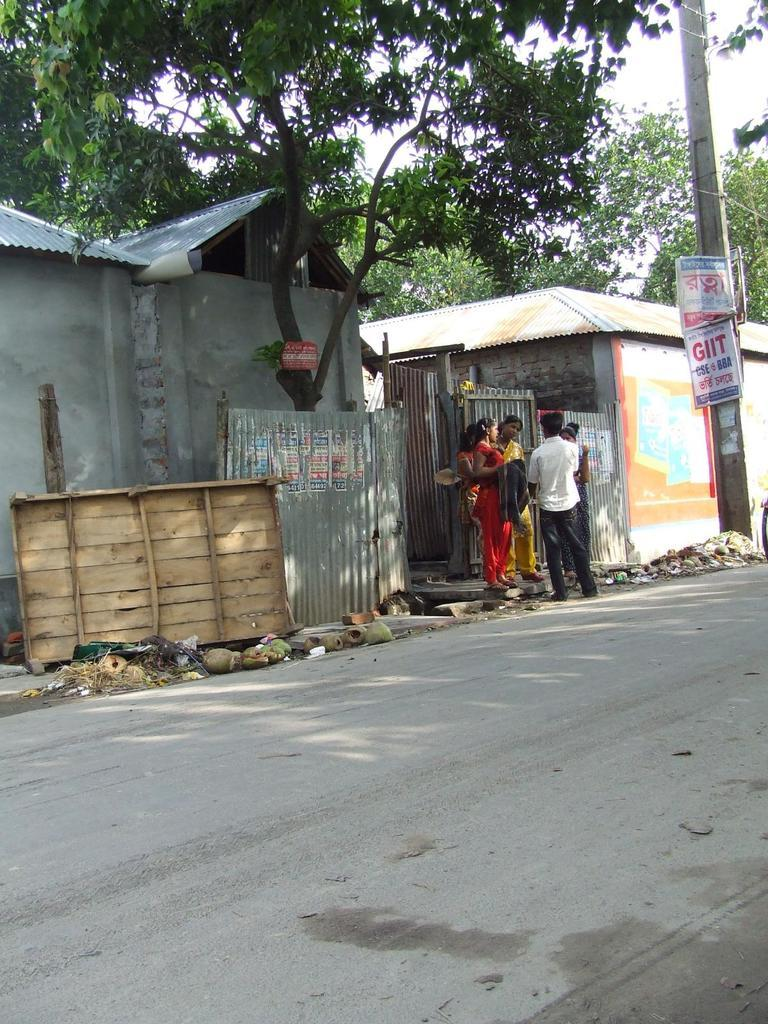What is located in the foreground of the image? There is a road in the foreground of the image. What can be seen in the background of the image? In the background of the image, there is a pole, banners, persons standing, a wooden object, metal sheets, two houses, trees, and the sky. How many houses are visible in the background of the image? There are two houses visible in the background of the image. What type of objects are present in the background of the image? In the background of the image, there are a pole, banners, a wooden object, and metal sheets. How many kittens are playing with the metal sheets in the image? There are no kittens present in the image. 